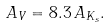Convert formula to latex. <formula><loc_0><loc_0><loc_500><loc_500>A _ { V } = 8 . 3 \, A _ { K _ { s } } .</formula> 